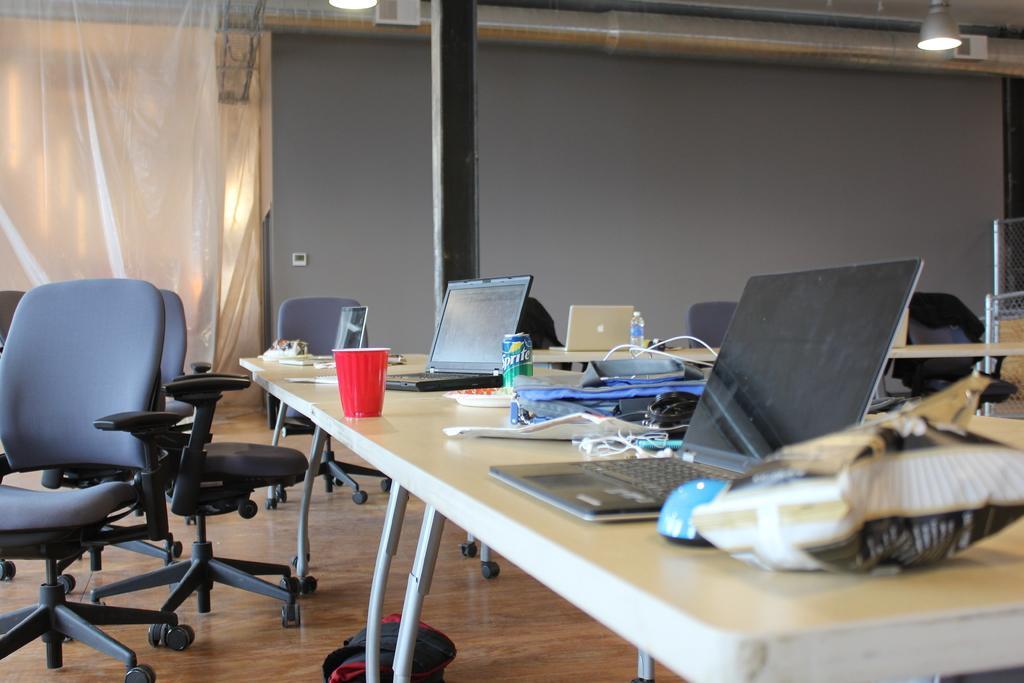Please provide a concise description of this image. In the center of the image there is a table on which there are laptops,there is a sprite tin,there is a glass, there are other objects. There are many chairs. In the background of the image there is a wall. 